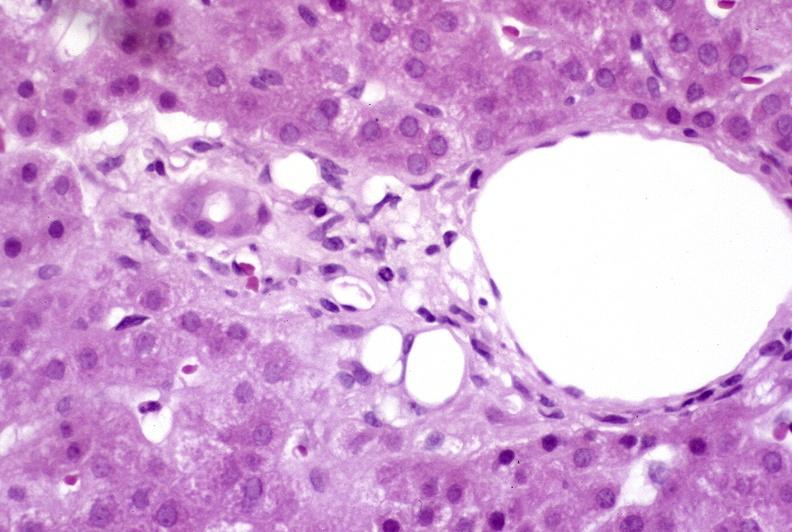s ectopic pancreas present?
Answer the question using a single word or phrase. No 